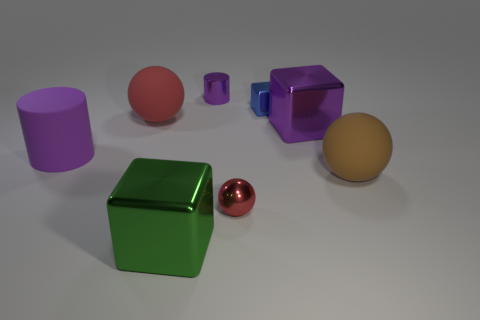There is a large object in front of the small metal sphere; does it have the same shape as the small blue object?
Offer a very short reply. Yes. What is the material of the big brown ball?
Provide a succinct answer. Rubber. What is the shape of the blue thing that is the same size as the shiny cylinder?
Offer a very short reply. Cube. Are there any metal objects of the same color as the small metal cylinder?
Give a very brief answer. Yes. There is a metal cylinder; is its color the same as the big shiny object to the right of the blue metal cube?
Provide a short and direct response. Yes. What is the color of the large metal object in front of the large shiny object behind the big brown ball?
Your answer should be compact. Green. Is there a rubber sphere that is on the left side of the big purple metallic cube in front of the big rubber object behind the large purple cylinder?
Your response must be concise. Yes. What is the color of the tiny block that is made of the same material as the tiny cylinder?
Keep it short and to the point. Blue. How many purple objects are the same material as the large red sphere?
Make the answer very short. 1. Is the material of the large brown object the same as the purple cylinder that is on the right side of the purple matte cylinder?
Your response must be concise. No. 